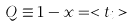Convert formula to latex. <formula><loc_0><loc_0><loc_500><loc_500>Q \equiv 1 - x = < t _ { i } ></formula> 